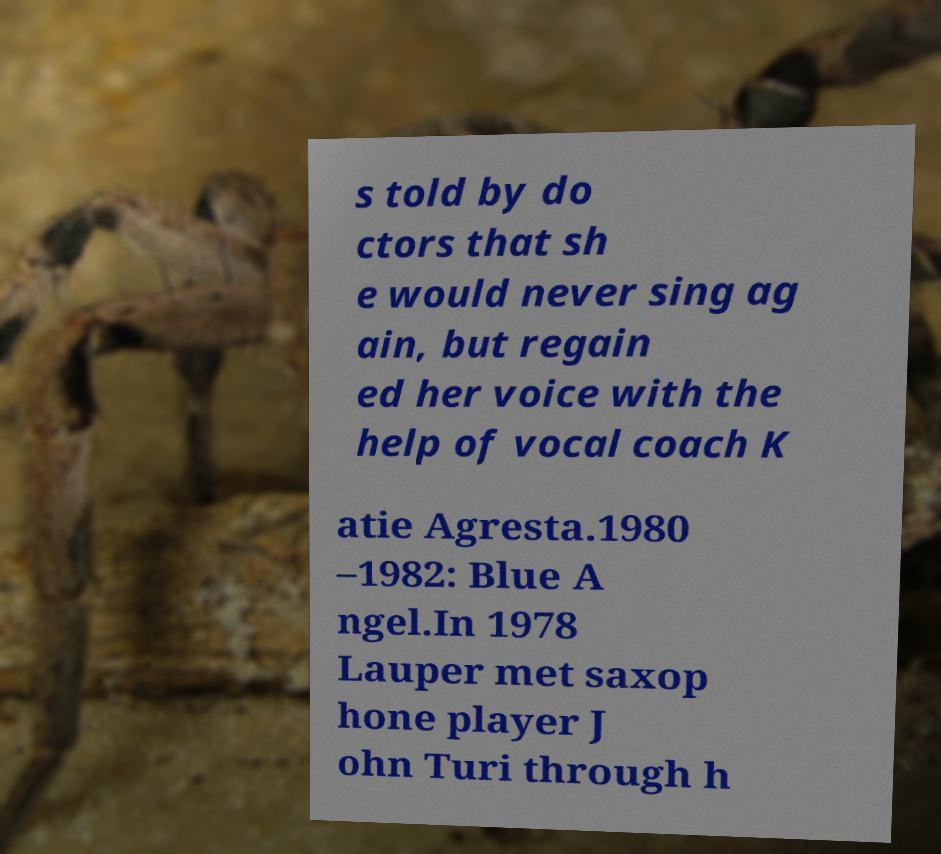Can you read and provide the text displayed in the image?This photo seems to have some interesting text. Can you extract and type it out for me? s told by do ctors that sh e would never sing ag ain, but regain ed her voice with the help of vocal coach K atie Agresta.1980 –1982: Blue A ngel.In 1978 Lauper met saxop hone player J ohn Turi through h 